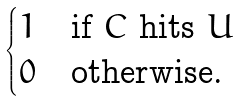Convert formula to latex. <formula><loc_0><loc_0><loc_500><loc_500>\begin{cases} 1 & \text {if } C \text { hits } U \\ 0 & \text {otherwise.} \end{cases}</formula> 